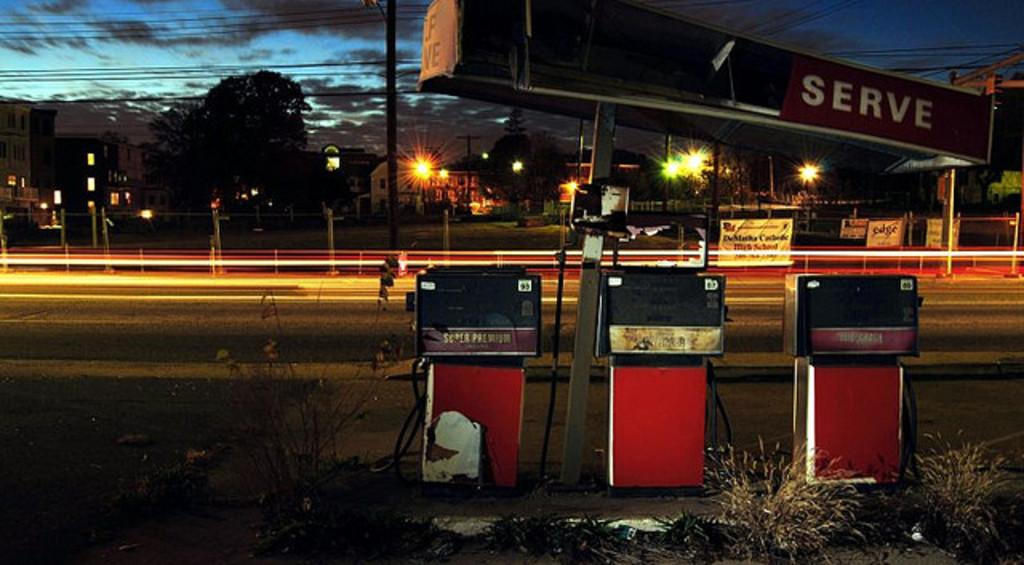What type of machines can be seen in the image? There are petrol pumping machines in the image. What type of vegetation is present in the image? There is grass and trees in the image. What type of signage is present in the image? There are banners in the image. What type of structures are present in the image? There are poles and buildings in the image. What type of illumination is present in the image? There are lights in the image. What type of cables are present in the image? There are cables in the image. What can be seen in the background of the image? The sky is visible in the background of the image. What type of credit card is being used to pay for the petrol in the image? There is no credit card or payment being depicted in the image; it only shows petrol pumping machines, grass, banners, poles, lights, trees, buildings, cables, and the sky in the background. Can you tell me how many birds are flying in the image? There are no birds or any indication of flying in the image. 